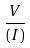Convert formula to latex. <formula><loc_0><loc_0><loc_500><loc_500>\frac { V } { ( I ) }</formula> 